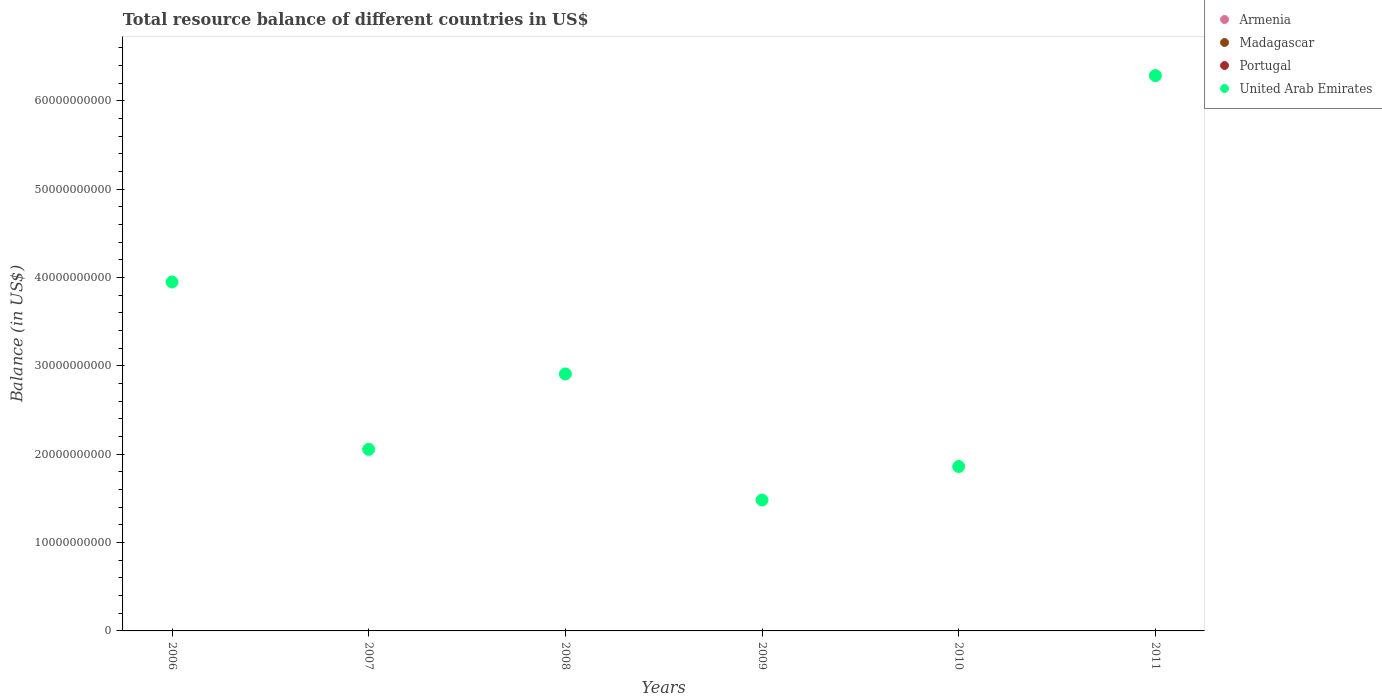How many different coloured dotlines are there?
Offer a terse response. 1. What is the total resource balance in Portugal in 2011?
Provide a short and direct response. 0. Across all years, what is the minimum total resource balance in Armenia?
Provide a short and direct response. 0. In which year was the total resource balance in United Arab Emirates maximum?
Keep it short and to the point. 2011. What is the total total resource balance in Madagascar in the graph?
Ensure brevity in your answer.  0. What is the difference between the total resource balance in United Arab Emirates in 2006 and that in 2010?
Keep it short and to the point. 2.09e+1. What is the difference between the total resource balance in Madagascar in 2006 and the total resource balance in Portugal in 2011?
Give a very brief answer. 0. What is the average total resource balance in Armenia per year?
Keep it short and to the point. 0. In how many years, is the total resource balance in Portugal greater than 62000000000 US$?
Offer a terse response. 0. What is the ratio of the total resource balance in United Arab Emirates in 2007 to that in 2008?
Keep it short and to the point. 0.71. What is the difference between the highest and the second highest total resource balance in United Arab Emirates?
Keep it short and to the point. 2.34e+1. What is the difference between the highest and the lowest total resource balance in United Arab Emirates?
Your answer should be compact. 4.81e+1. In how many years, is the total resource balance in Portugal greater than the average total resource balance in Portugal taken over all years?
Ensure brevity in your answer.  0. Is it the case that in every year, the sum of the total resource balance in Portugal and total resource balance in Madagascar  is greater than the sum of total resource balance in United Arab Emirates and total resource balance in Armenia?
Your answer should be compact. No. Is it the case that in every year, the sum of the total resource balance in United Arab Emirates and total resource balance in Armenia  is greater than the total resource balance in Portugal?
Your response must be concise. Yes. Does the total resource balance in Portugal monotonically increase over the years?
Your answer should be very brief. No. How many dotlines are there?
Ensure brevity in your answer.  1. What is the difference between two consecutive major ticks on the Y-axis?
Offer a very short reply. 1.00e+1. Are the values on the major ticks of Y-axis written in scientific E-notation?
Your answer should be very brief. No. Does the graph contain grids?
Keep it short and to the point. No. How are the legend labels stacked?
Make the answer very short. Vertical. What is the title of the graph?
Offer a terse response. Total resource balance of different countries in US$. What is the label or title of the Y-axis?
Make the answer very short. Balance (in US$). What is the Balance (in US$) in Armenia in 2006?
Make the answer very short. 0. What is the Balance (in US$) in Madagascar in 2006?
Provide a succinct answer. 0. What is the Balance (in US$) of United Arab Emirates in 2006?
Offer a very short reply. 3.95e+1. What is the Balance (in US$) of Armenia in 2007?
Your response must be concise. 0. What is the Balance (in US$) of Madagascar in 2007?
Your answer should be very brief. 0. What is the Balance (in US$) of United Arab Emirates in 2007?
Offer a terse response. 2.06e+1. What is the Balance (in US$) in Portugal in 2008?
Give a very brief answer. 0. What is the Balance (in US$) of United Arab Emirates in 2008?
Your answer should be compact. 2.91e+1. What is the Balance (in US$) in Armenia in 2009?
Keep it short and to the point. 0. What is the Balance (in US$) of Portugal in 2009?
Provide a succinct answer. 0. What is the Balance (in US$) of United Arab Emirates in 2009?
Offer a very short reply. 1.48e+1. What is the Balance (in US$) of United Arab Emirates in 2010?
Offer a very short reply. 1.86e+1. What is the Balance (in US$) in Armenia in 2011?
Provide a short and direct response. 0. What is the Balance (in US$) in Madagascar in 2011?
Make the answer very short. 0. What is the Balance (in US$) of Portugal in 2011?
Offer a very short reply. 0. What is the Balance (in US$) in United Arab Emirates in 2011?
Ensure brevity in your answer.  6.29e+1. Across all years, what is the maximum Balance (in US$) of United Arab Emirates?
Offer a very short reply. 6.29e+1. Across all years, what is the minimum Balance (in US$) of United Arab Emirates?
Provide a succinct answer. 1.48e+1. What is the total Balance (in US$) in United Arab Emirates in the graph?
Provide a short and direct response. 1.85e+11. What is the difference between the Balance (in US$) in United Arab Emirates in 2006 and that in 2007?
Offer a terse response. 1.89e+1. What is the difference between the Balance (in US$) in United Arab Emirates in 2006 and that in 2008?
Offer a terse response. 1.04e+1. What is the difference between the Balance (in US$) in United Arab Emirates in 2006 and that in 2009?
Give a very brief answer. 2.47e+1. What is the difference between the Balance (in US$) of United Arab Emirates in 2006 and that in 2010?
Give a very brief answer. 2.09e+1. What is the difference between the Balance (in US$) in United Arab Emirates in 2006 and that in 2011?
Give a very brief answer. -2.34e+1. What is the difference between the Balance (in US$) of United Arab Emirates in 2007 and that in 2008?
Your answer should be very brief. -8.54e+09. What is the difference between the Balance (in US$) in United Arab Emirates in 2007 and that in 2009?
Your response must be concise. 5.74e+09. What is the difference between the Balance (in US$) in United Arab Emirates in 2007 and that in 2010?
Give a very brief answer. 1.94e+09. What is the difference between the Balance (in US$) of United Arab Emirates in 2007 and that in 2011?
Provide a succinct answer. -4.23e+1. What is the difference between the Balance (in US$) of United Arab Emirates in 2008 and that in 2009?
Give a very brief answer. 1.43e+1. What is the difference between the Balance (in US$) in United Arab Emirates in 2008 and that in 2010?
Provide a short and direct response. 1.05e+1. What is the difference between the Balance (in US$) of United Arab Emirates in 2008 and that in 2011?
Ensure brevity in your answer.  -3.38e+1. What is the difference between the Balance (in US$) of United Arab Emirates in 2009 and that in 2010?
Ensure brevity in your answer.  -3.79e+09. What is the difference between the Balance (in US$) of United Arab Emirates in 2009 and that in 2011?
Provide a short and direct response. -4.81e+1. What is the difference between the Balance (in US$) of United Arab Emirates in 2010 and that in 2011?
Provide a short and direct response. -4.43e+1. What is the average Balance (in US$) of Madagascar per year?
Your answer should be very brief. 0. What is the average Balance (in US$) of Portugal per year?
Offer a terse response. 0. What is the average Balance (in US$) of United Arab Emirates per year?
Give a very brief answer. 3.09e+1. What is the ratio of the Balance (in US$) of United Arab Emirates in 2006 to that in 2007?
Offer a terse response. 1.92. What is the ratio of the Balance (in US$) in United Arab Emirates in 2006 to that in 2008?
Your answer should be compact. 1.36. What is the ratio of the Balance (in US$) of United Arab Emirates in 2006 to that in 2009?
Provide a succinct answer. 2.67. What is the ratio of the Balance (in US$) of United Arab Emirates in 2006 to that in 2010?
Give a very brief answer. 2.12. What is the ratio of the Balance (in US$) of United Arab Emirates in 2006 to that in 2011?
Your answer should be very brief. 0.63. What is the ratio of the Balance (in US$) of United Arab Emirates in 2007 to that in 2008?
Offer a very short reply. 0.71. What is the ratio of the Balance (in US$) of United Arab Emirates in 2007 to that in 2009?
Your answer should be very brief. 1.39. What is the ratio of the Balance (in US$) of United Arab Emirates in 2007 to that in 2010?
Offer a terse response. 1.1. What is the ratio of the Balance (in US$) in United Arab Emirates in 2007 to that in 2011?
Offer a very short reply. 0.33. What is the ratio of the Balance (in US$) of United Arab Emirates in 2008 to that in 2009?
Your response must be concise. 1.96. What is the ratio of the Balance (in US$) in United Arab Emirates in 2008 to that in 2010?
Keep it short and to the point. 1.56. What is the ratio of the Balance (in US$) of United Arab Emirates in 2008 to that in 2011?
Provide a short and direct response. 0.46. What is the ratio of the Balance (in US$) of United Arab Emirates in 2009 to that in 2010?
Offer a terse response. 0.8. What is the ratio of the Balance (in US$) of United Arab Emirates in 2009 to that in 2011?
Make the answer very short. 0.24. What is the ratio of the Balance (in US$) in United Arab Emirates in 2010 to that in 2011?
Your answer should be very brief. 0.3. What is the difference between the highest and the second highest Balance (in US$) of United Arab Emirates?
Give a very brief answer. 2.34e+1. What is the difference between the highest and the lowest Balance (in US$) in United Arab Emirates?
Offer a terse response. 4.81e+1. 